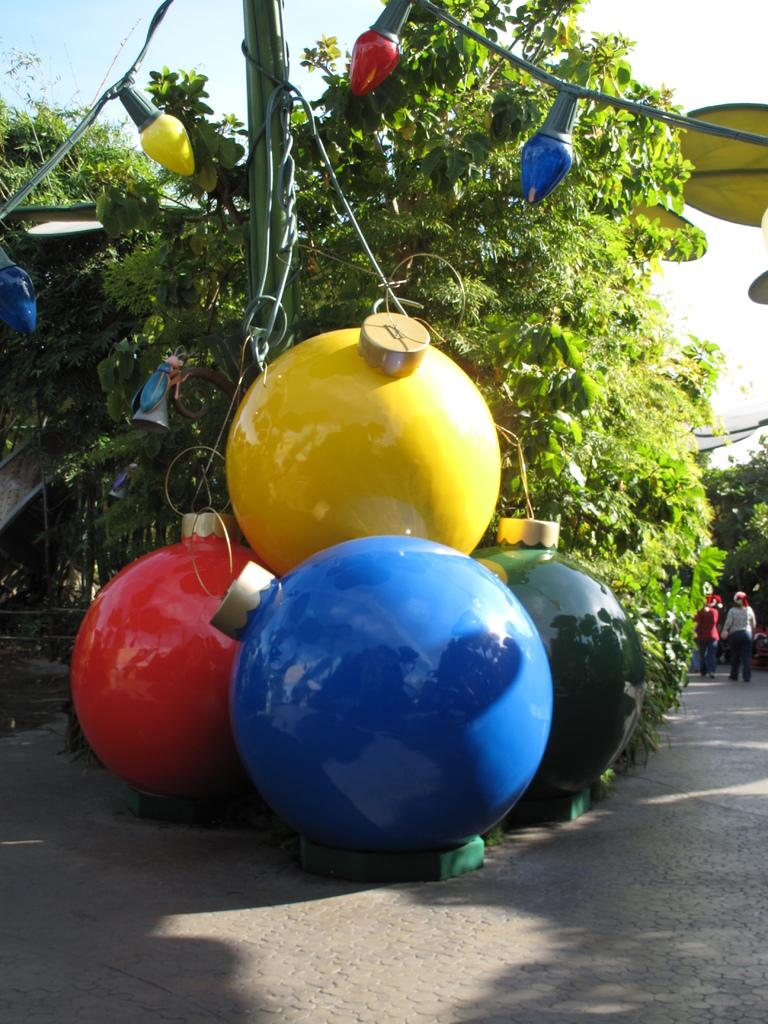What colors are the lights in the image? The lights in the image are in yellow, red, blue, and green colors. What can be seen in the background of the image? There are people walking and trees with green color in the background of the image. What colors are visible in the sky in the image? The sky has a combination of white and blue colors in the background of the image. How many cars are parked near the wall in the image? There is no wall or cars present in the image. 